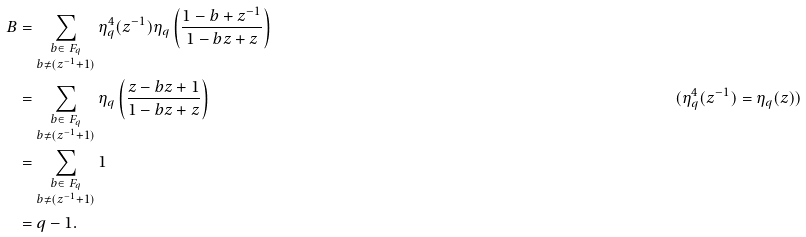Convert formula to latex. <formula><loc_0><loc_0><loc_500><loc_500>B & = \sum _ { \substack { b \in \ F _ { q } \\ b \neq ( z ^ { - 1 } + 1 ) } } \eta ^ { 4 } _ { q } ( z ^ { - 1 } ) \eta _ { q } \left ( \frac { 1 - b + z ^ { - 1 } } { 1 - b z + z } \right ) \\ & = \sum _ { \substack { b \in \ F _ { q } \\ b \neq ( z ^ { - 1 } + 1 ) } } \eta _ { q } \left ( \frac { z - b z + 1 } { 1 - b z + z } \right ) & ( \eta _ { q } ^ { 4 } ( z ^ { - 1 } ) = \eta _ { q } ( z ) ) \\ & = \sum _ { \substack { b \in \ F _ { q } \\ b \neq ( z ^ { - 1 } + 1 ) } } 1 \\ & = q - 1 .</formula> 